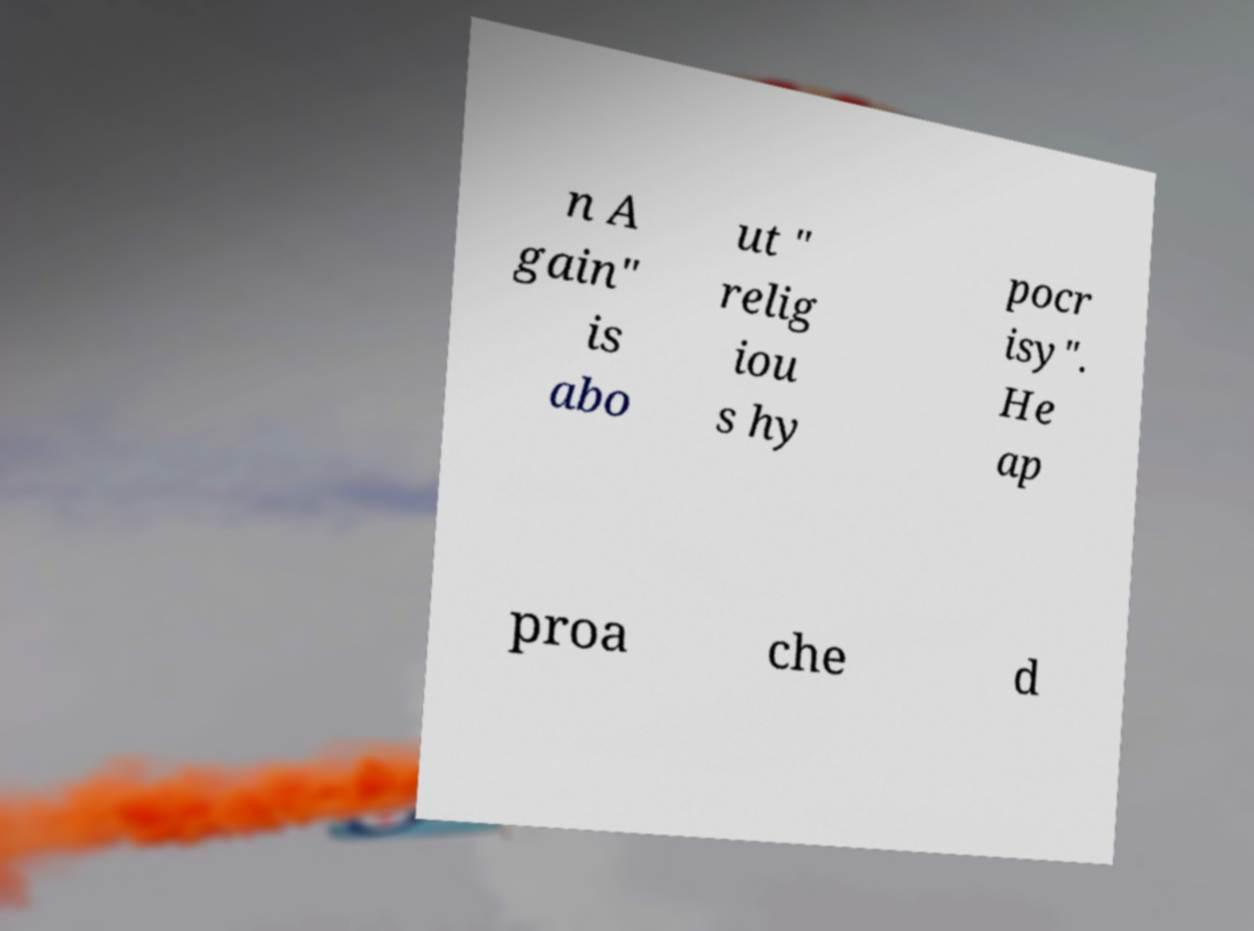I need the written content from this picture converted into text. Can you do that? n A gain" is abo ut " relig iou s hy pocr isy". He ap proa che d 